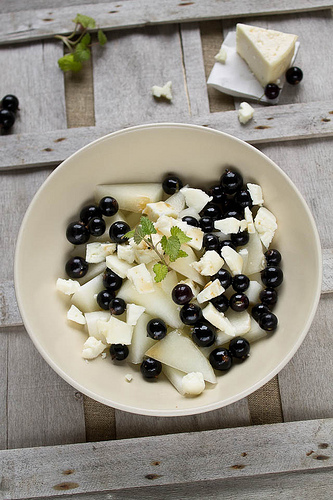<image>
Is the mint on the crate? Yes. Looking at the image, I can see the mint is positioned on top of the crate, with the crate providing support. Is the cheese in the bowl? No. The cheese is not contained within the bowl. These objects have a different spatial relationship. 